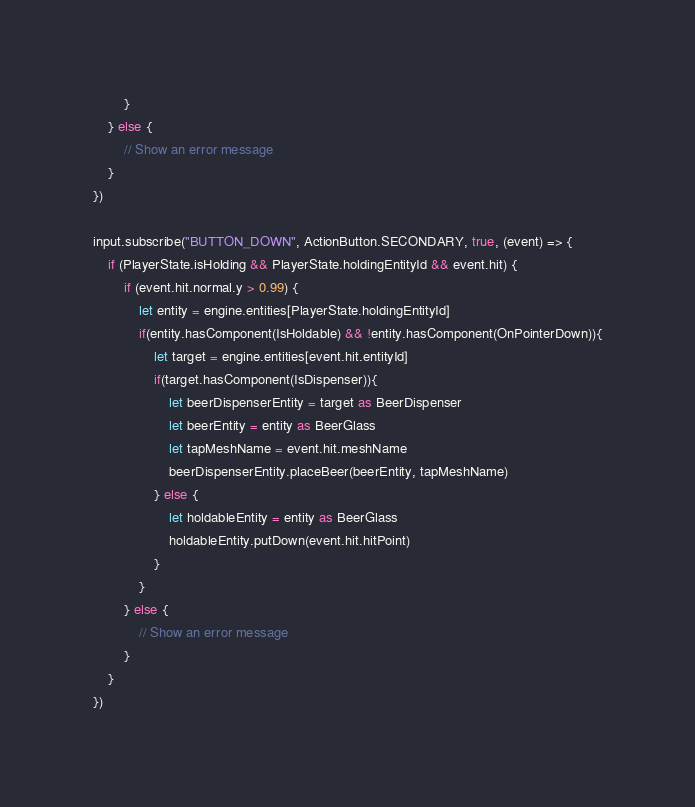Convert code to text. <code><loc_0><loc_0><loc_500><loc_500><_TypeScript_>        }
    } else {
        // Show an error message
    }
})
  
input.subscribe("BUTTON_DOWN", ActionButton.SECONDARY, true, (event) => {
    if (PlayerState.isHolding && PlayerState.holdingEntityId && event.hit) {
        if (event.hit.normal.y > 0.99) {
            let entity = engine.entities[PlayerState.holdingEntityId]
            if(entity.hasComponent(IsHoldable) && !entity.hasComponent(OnPointerDown)){
                let target = engine.entities[event.hit.entityId]
                if(target.hasComponent(IsDispenser)){
                    let beerDispenserEntity = target as BeerDispenser
                    let beerEntity = entity as BeerGlass
                    let tapMeshName = event.hit.meshName
                    beerDispenserEntity.placeBeer(beerEntity, tapMeshName)
                } else {
                    let holdableEntity = entity as BeerGlass
                    holdableEntity.putDown(event.hit.hitPoint)
                }
            }
        } else {
            // Show an error message
        }
    }
})
</code> 